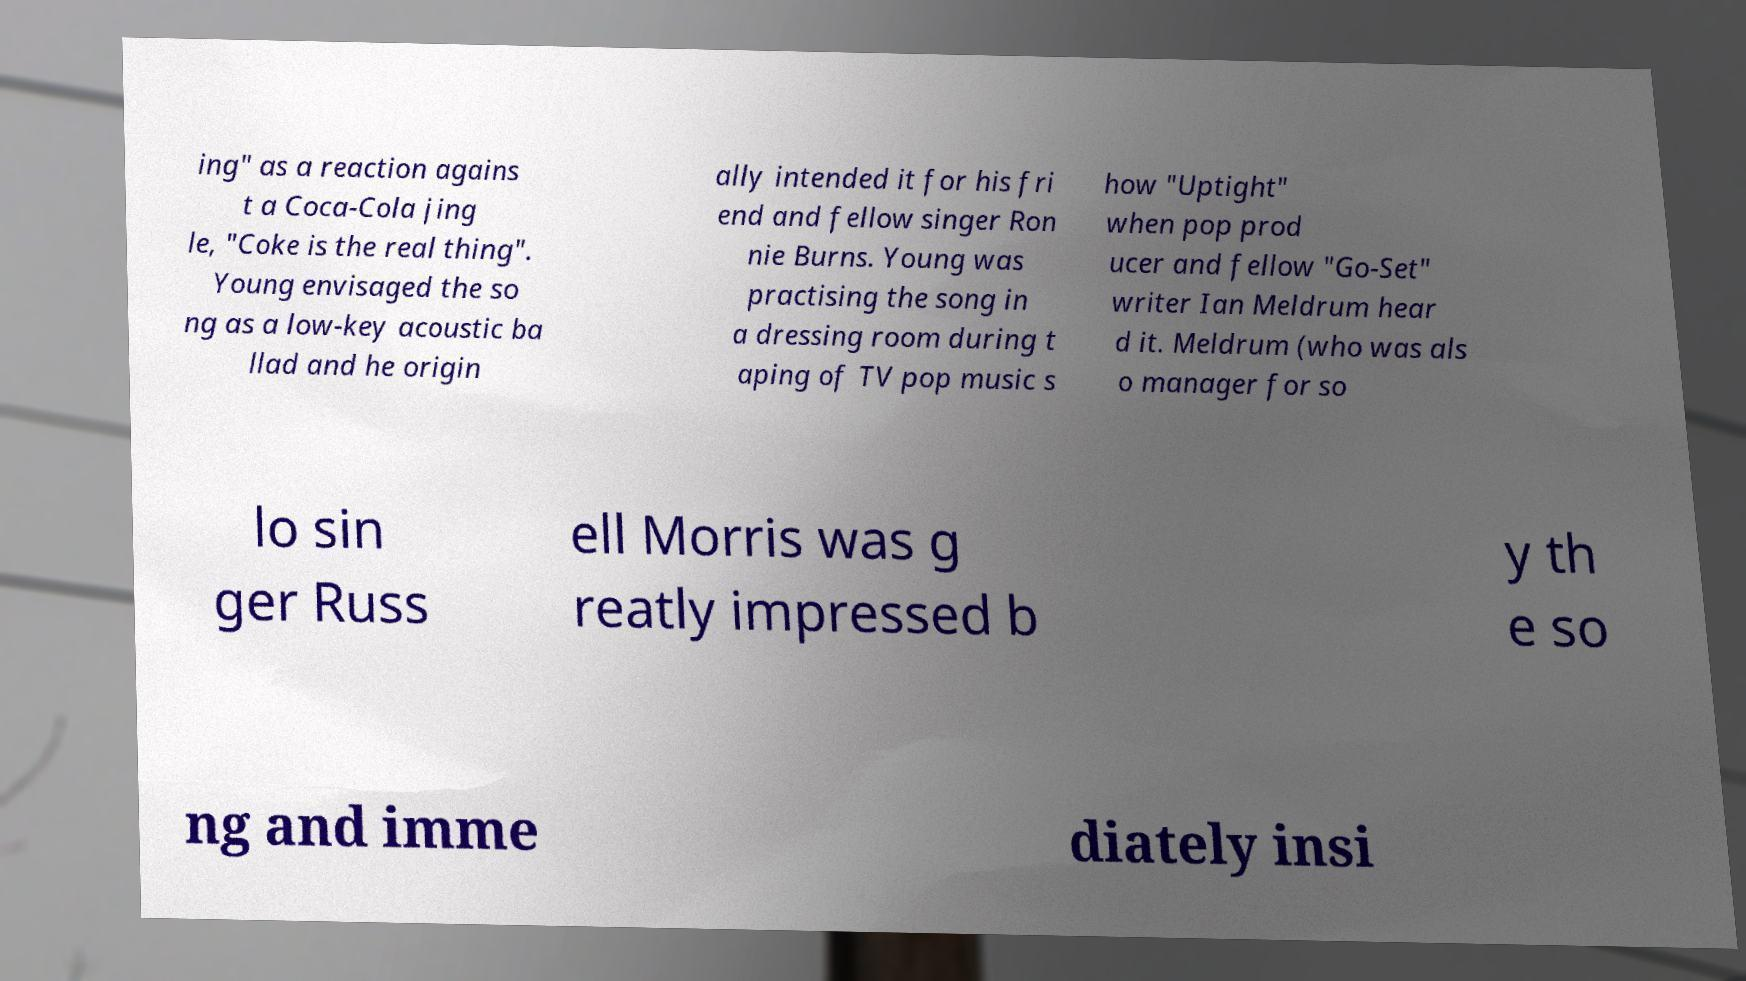Please read and relay the text visible in this image. What does it say? ing" as a reaction agains t a Coca-Cola jing le, "Coke is the real thing". Young envisaged the so ng as a low-key acoustic ba llad and he origin ally intended it for his fri end and fellow singer Ron nie Burns. Young was practising the song in a dressing room during t aping of TV pop music s how "Uptight" when pop prod ucer and fellow "Go-Set" writer Ian Meldrum hear d it. Meldrum (who was als o manager for so lo sin ger Russ ell Morris was g reatly impressed b y th e so ng and imme diately insi 